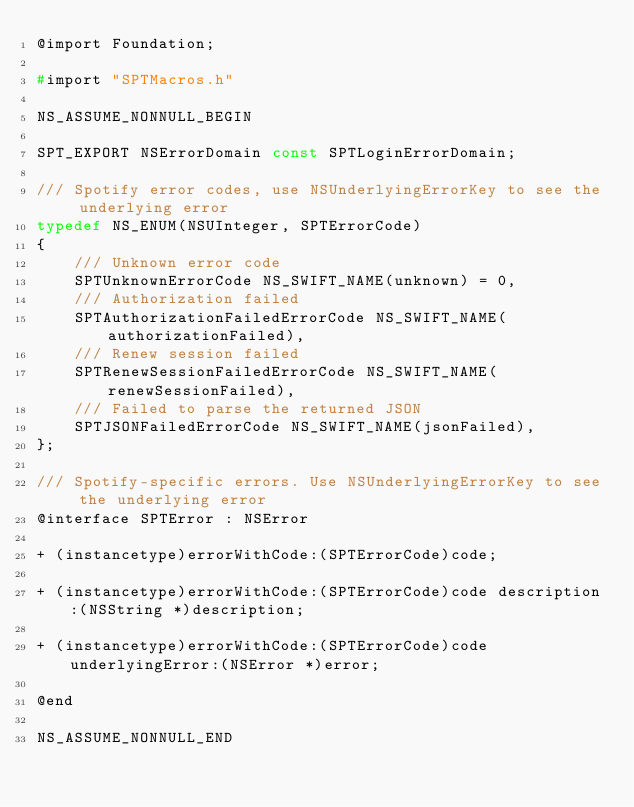Convert code to text. <code><loc_0><loc_0><loc_500><loc_500><_C_>@import Foundation;

#import "SPTMacros.h"

NS_ASSUME_NONNULL_BEGIN

SPT_EXPORT NSErrorDomain const SPTLoginErrorDomain;

/// Spotify error codes, use NSUnderlyingErrorKey to see the underlying error
typedef NS_ENUM(NSUInteger, SPTErrorCode)
{
    /// Unknown error code
    SPTUnknownErrorCode NS_SWIFT_NAME(unknown) = 0,
    /// Authorization failed
    SPTAuthorizationFailedErrorCode NS_SWIFT_NAME(authorizationFailed),
    /// Renew session failed
    SPTRenewSessionFailedErrorCode NS_SWIFT_NAME(renewSessionFailed),
    /// Failed to parse the returned JSON
    SPTJSONFailedErrorCode NS_SWIFT_NAME(jsonFailed),
};

/// Spotify-specific errors. Use NSUnderlyingErrorKey to see the underlying error
@interface SPTError : NSError

+ (instancetype)errorWithCode:(SPTErrorCode)code;

+ (instancetype)errorWithCode:(SPTErrorCode)code description:(NSString *)description;

+ (instancetype)errorWithCode:(SPTErrorCode)code underlyingError:(NSError *)error;

@end

NS_ASSUME_NONNULL_END
</code> 